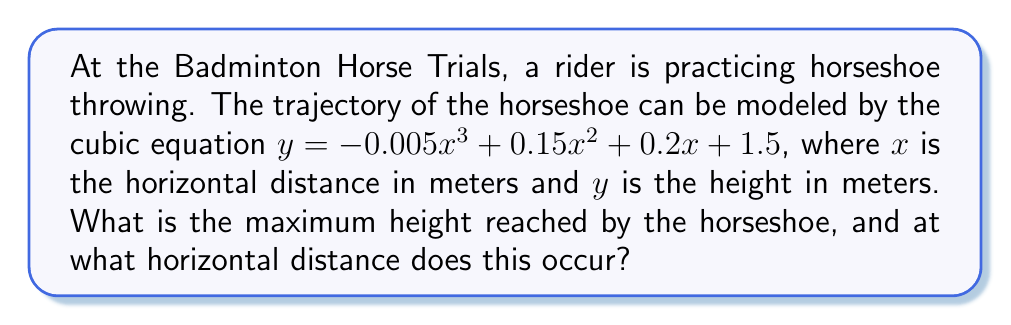Can you solve this math problem? To find the maximum height of the horseshoe's trajectory, we need to find the local maximum of the given cubic function. This occurs where the first derivative of the function is zero.

1) First, let's find the derivative of the function:
   $\frac{dy}{dx} = -0.015x^2 + 0.3x + 0.2$

2) Set this equal to zero:
   $-0.015x^2 + 0.3x + 0.2 = 0$

3) This is a quadratic equation. We can solve it using the quadratic formula:
   $x = \frac{-b \pm \sqrt{b^2 - 4ac}}{2a}$

   Where $a = -0.015$, $b = 0.3$, and $c = 0.2$

4) Substituting these values:
   $x = \frac{-0.3 \pm \sqrt{0.3^2 - 4(-0.015)(0.2)}}{2(-0.015)}$

5) Simplifying:
   $x = \frac{-0.3 \pm \sqrt{0.09 + 0.012}}{-0.03} = \frac{-0.3 \pm \sqrt{0.102}}{-0.03}$

6) This gives us two solutions:
   $x_1 \approx 13.33$ and $x_2 \approx 6.67$

7) The positive solution that's less than 13.33 (as the horseshoe is thrown forward) is $x \approx 6.67$ meters.

8) To find the maximum height, substitute this x-value back into the original equation:
   $y = -0.005(6.67)^3 + 0.15(6.67)^2 + 0.2(6.67) + 1.5$

9) Calculating this gives us:
   $y \approx 3.97$ meters
Answer: The horseshoe reaches its maximum height of approximately 3.97 meters at a horizontal distance of about 6.67 meters. 